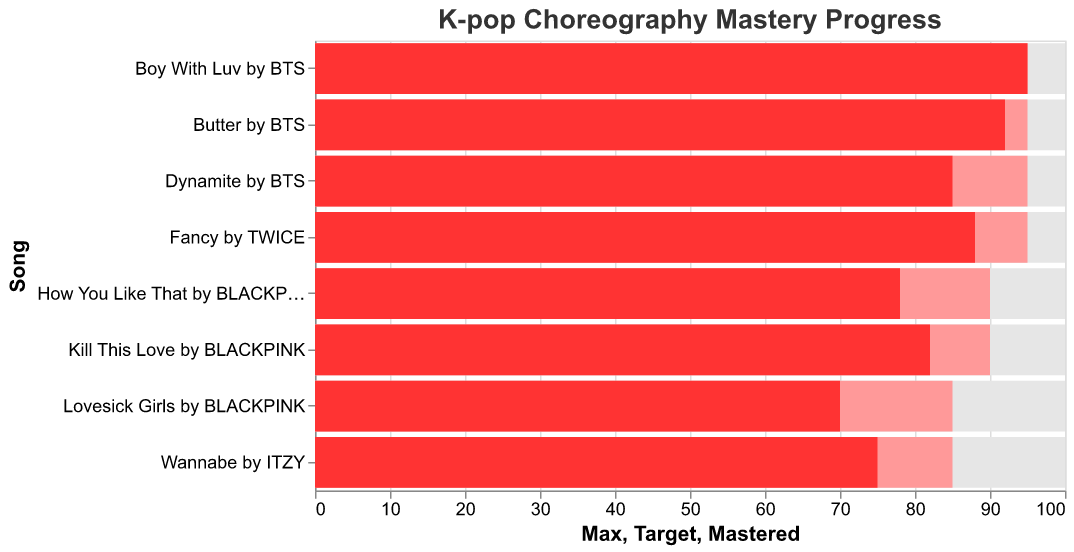what is the title of the chart? The title is displayed on top of the chart. It reads "K-pop Choreography Mastery Progress" with a bold font setting.
Answer: K-pop Choreography Mastery Progress Which song has the highest mastered percentage? The "Mastered" bar that reaches the farthest right represents the highest mastered percentage. For "Boy With Luv" by BTS, the mastered percentage is 95%.
Answer: Boy With Luv by BTS What is the target percentage for "Wannabe" by ITZY? The "Target" bar for "Wannabe" by ITZY, which is colored differently from the mastered bar, indicates a target of 85%.
Answer: 85% How many songs have a mastered percentage greater than 80%? Count the number of "Mastered" bars that go beyond the 80% mark. The songs are "Dynamite" by BTS, "How You Like That" by BLACKPINK, "Butter" by BTS, "Fancy" by TWICE, "Boy With Luv" by BTS, and "Kill This Love" by BLACKPINK. There are six songs.
Answer: 6 Which song has the least difference between the mastered percentage and the target percentage? Calculate the difference between the mastered and target percentages for each song. "Boy With Luv" by BTS has a mastered percentage of 95% and a target percentage of 95%, resulting in a difference of 0%.
Answer: Boy With Luv by BTS What's the average mastered percentage for songs by BTS? The mastered percentages for BTS songs are "Dynamite" (85), "Butter" (92), and "Boy With Luv" (95). The average is (85 + 92 + 95) / 3 = 90.67.
Answer: 90.67 Which song has the largest gap between the mastered percentage and 100%? Subtract the mastered percentage from 100 for each song. "Lovesick Girls" by BLACKPINK, with a mastered percentage of 70%, has the largest gap: 100 - 70 = 30.
Answer: Lovesick Girls by BLACKPINK What is the range of target percentages displayed on the chart? Identify the minimal and maximal target percentages. The minimal target percentage is for "Lovesick Girls" by BLACKPINK (85%) and the maximal is for "Dynamite" by BTS (95%). The range is 95 - 85 = 10.
Answer: 10 Which BLACKPINK song has mastered percentages in descending order? Look at the percentages for BLACKPINK songs and arrange them from high to low: "How You Like That" (78%), "Kill This Love" (82%), "Lovesick Girls" (70%). "Kill This Love" comes first, then "How You Like That", and finally "Lovesick Girls".
Answer: Kill This Love, How You Like That, Lovesick Girls 